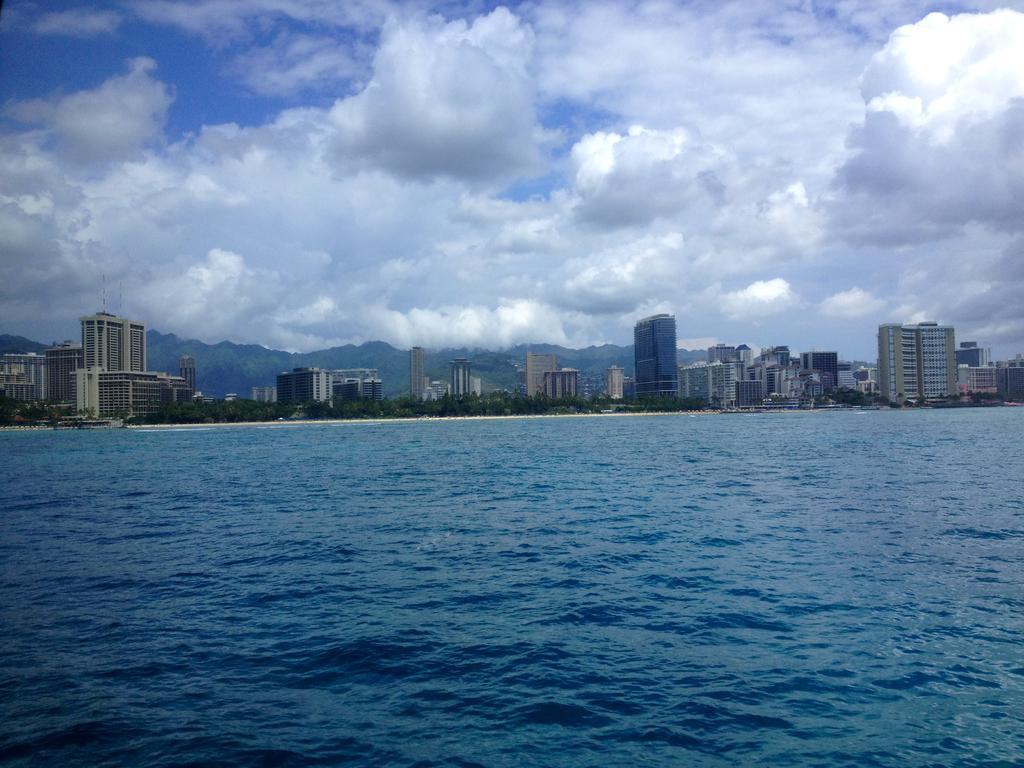Describe this image in one or two sentences. In this picture I can see the water in front and in the background I can see number of buildings, trees and the sky which is a bit cloudy. 